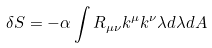<formula> <loc_0><loc_0><loc_500><loc_500>\delta S = - \alpha \int R _ { \mu \nu } k ^ { \mu } k ^ { \nu } \lambda d \lambda d A</formula> 